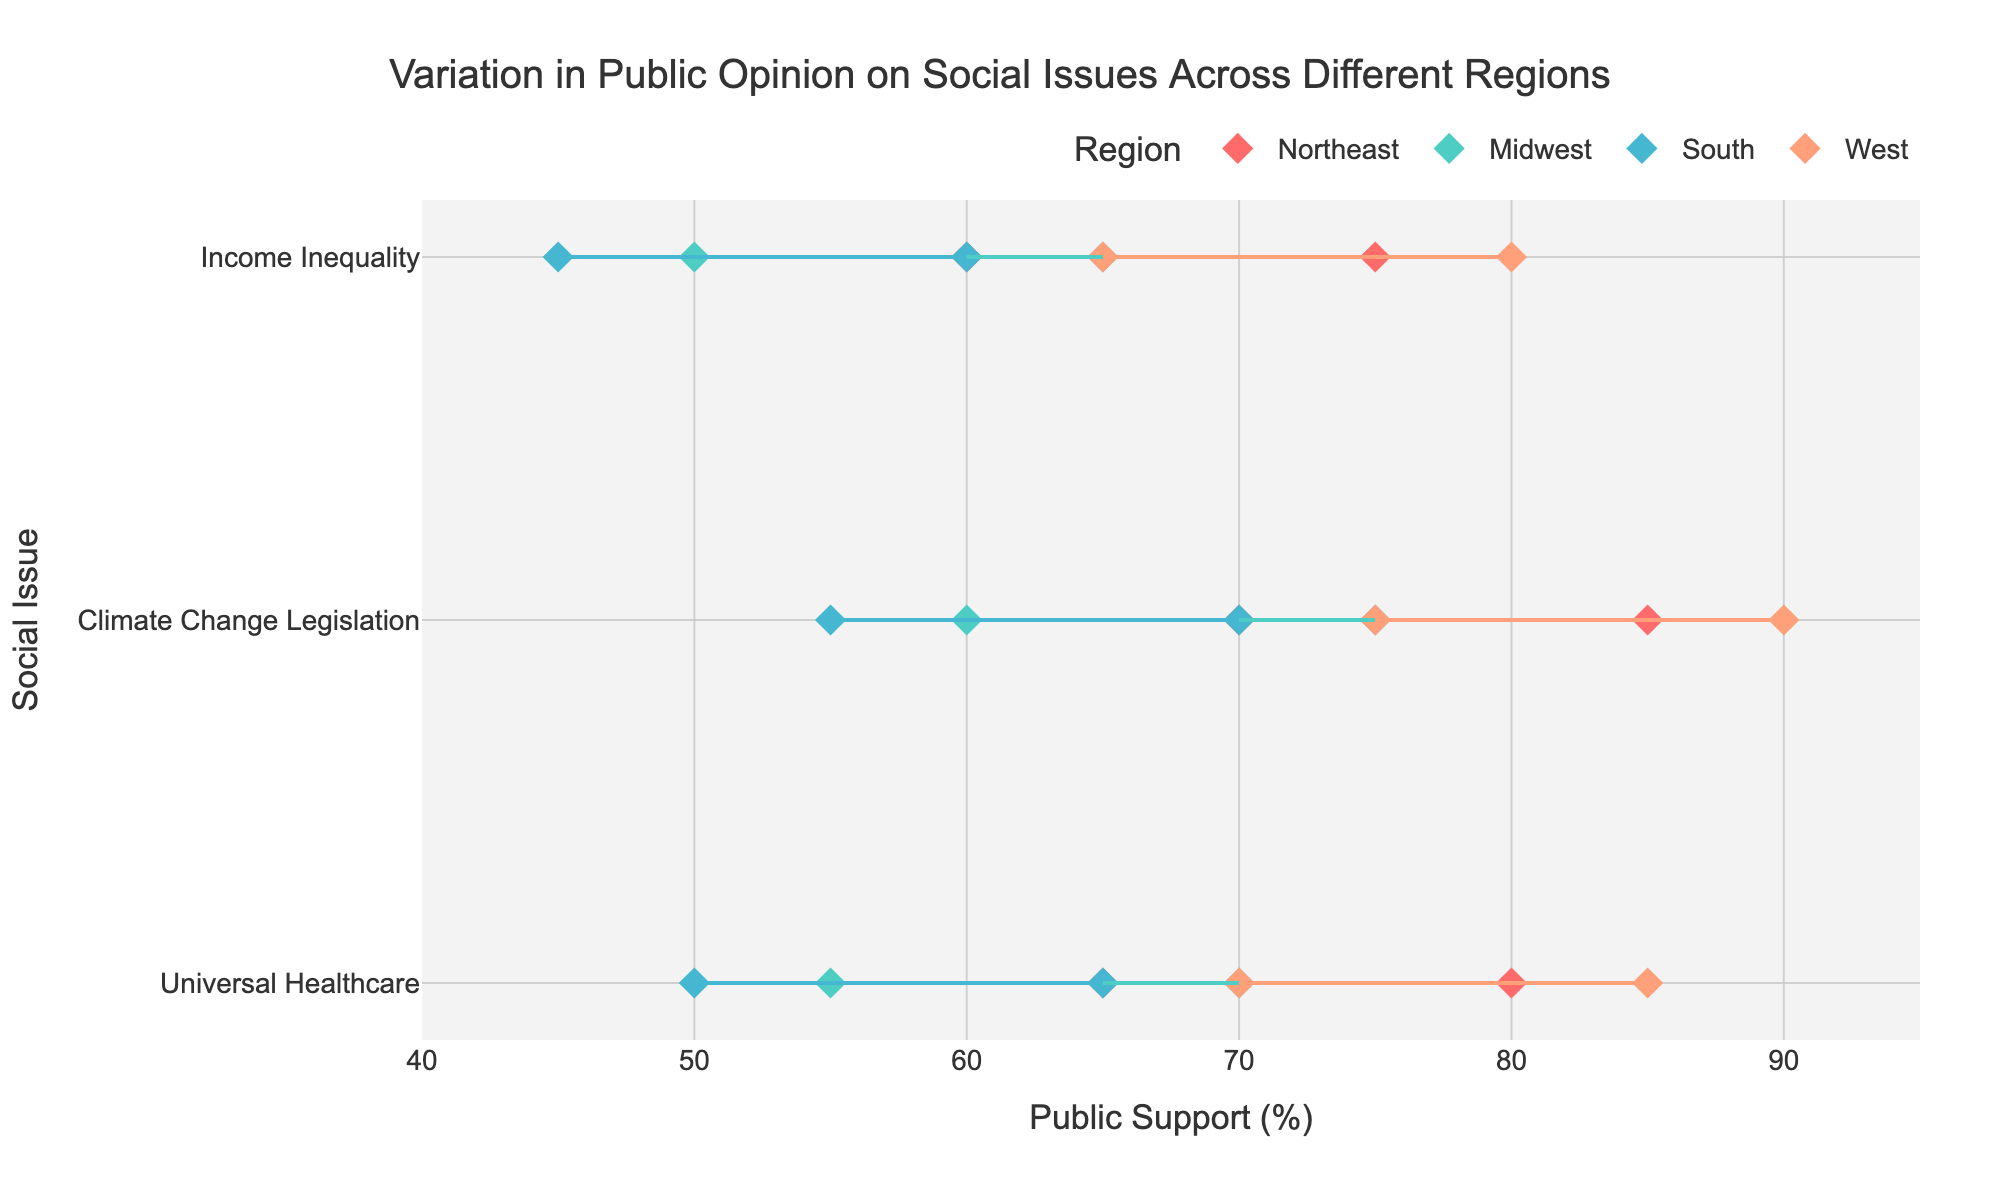What region shows the highest maximum support for Climate Change Legislation? The West region has a maximum support of 90% for Climate Change Legislation, which is higher than the other regions.
Answer: West What is the range of public support for Universal Healthcare in the Midwest? The range is calculated by subtracting the minimum support from the maximum support (70% - 55%).
Answer: 15% Which social issue in the South has the lowest minimum public support? By examining the data points for the South, Income Inequality has the lowest minimum public support with 45%.
Answer: Income Inequality Which region has the smallest variation in public opinions on Income Inequality? To determine the smallest variation, we find the range for each region's public support on Income Inequality and compare them. The smallest range is for the South (60% - 45%) which equals 15%.
Answer: South How does the public support for Climate Change Legislation in the Midwest compare to that in the Northeast? In the Midwest, public support ranges from 60% to 75%, while in the Northeast it ranges from 70% to 85%. This indicates that the Northeast has higher public support.
Answer: Northeast Which region shows the highest public support for Universal Healthcare? The West region shows the highest public support for Universal Healthcare with a maximum of 85%.
Answer: West What is the average maximum support for all social issues in the South? The maximum support values in the South are 65% for Universal Healthcare, 70% for Climate Change Legislation, and 60% for Income Inequality. The average is calculated as (65 + 70 + 60) / 3 = 65%.
Answer: 65% Which region has the widest variation in public opinion on Climate Change Legislation? To find the widest variation, we calculate the range for each region and compare. The West has the widest range for Climate Change Legislation with a variation of 15% (90% - 75%).
Answer: West What is the total number of regions analyzed in the plot? There are four regions analyzed in the plot: Northeast, Midwest, South, and West.
Answer: Four Comparing public support for Income Inequality and Universal Healthcare in the West, which has higher maximum support? In the West, Universal Healthcare has a maximum support of 85%, and Income Inequality has a maximum support of 80%. Universal Healthcare has higher maximum support.
Answer: Universal Healthcare 